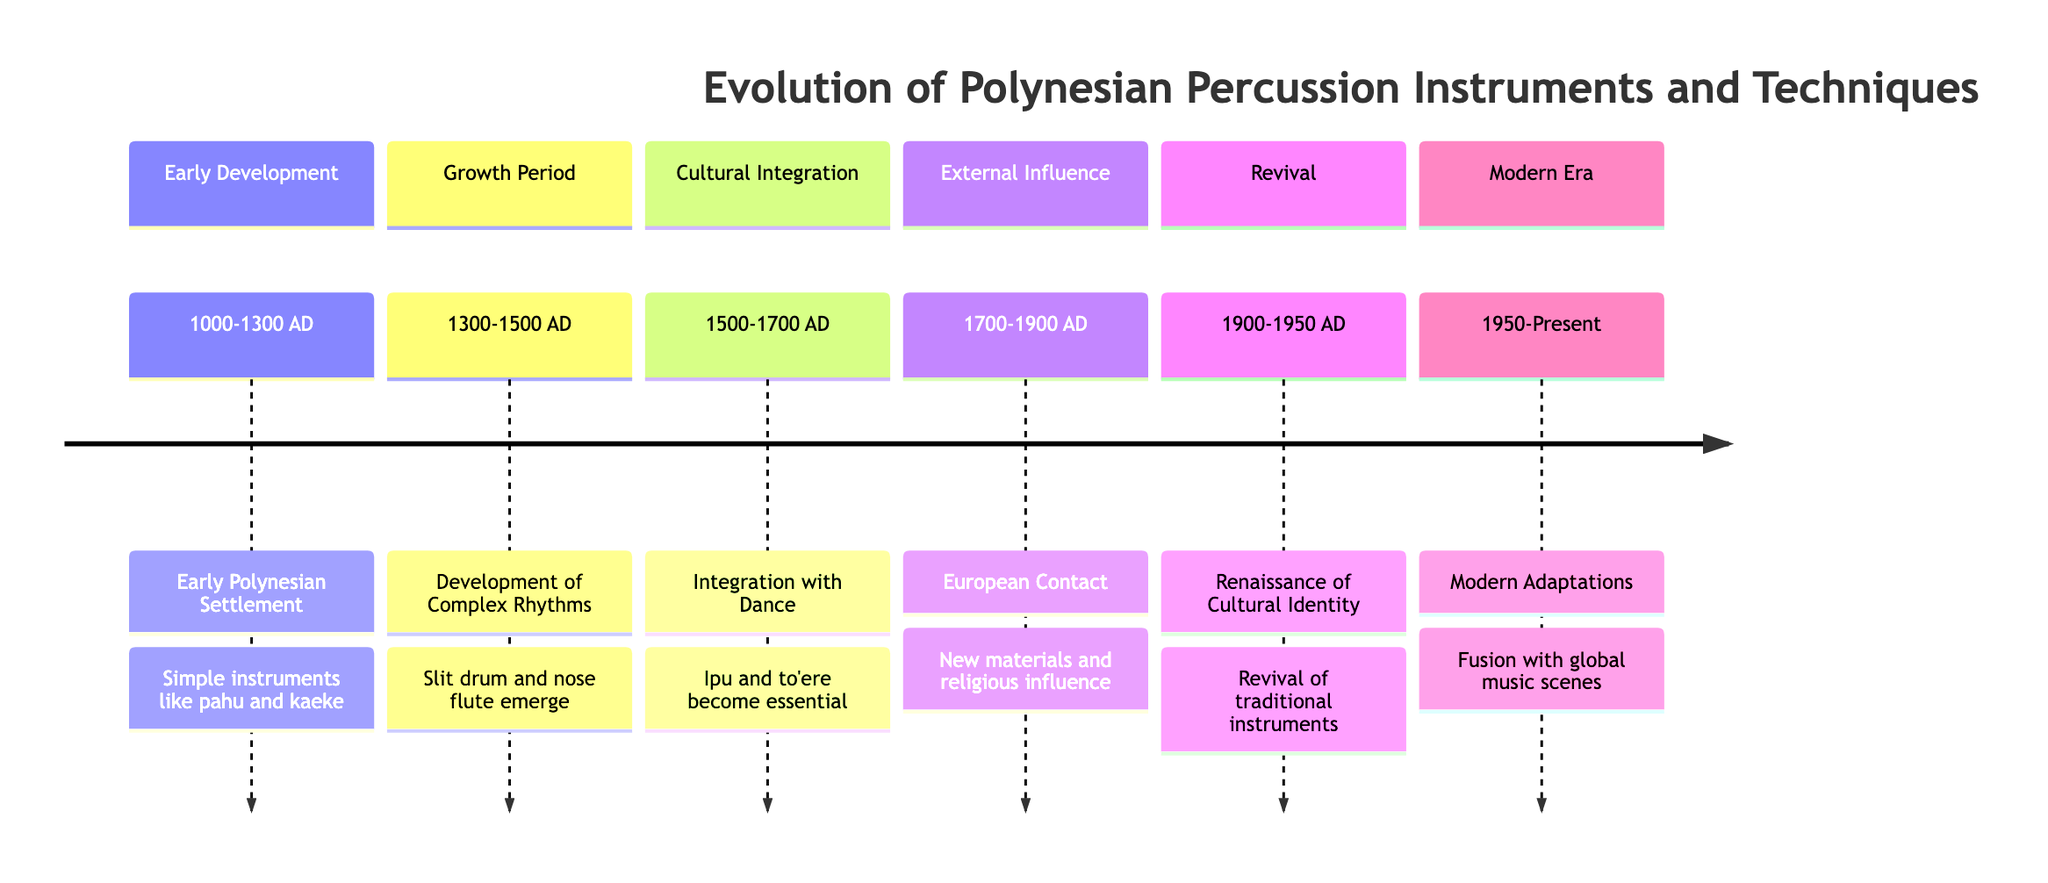What period marks the early Polynesian settlement? The timeline states that the early Polynesian settlement occurred from 1000 to 1300 AD. This period is the first entry in the timeline, indicating it is chronologically the earliest event listed.
Answer: 1000-1300 AD Which percussion instruments were mentioned in the early development section? The early development section lists the simple instruments introduced during the early Polynesian settlement, specifically mentioning pahu (drums) and kaeke (log drums) as crucial to rituals and entertainment.
Answer: pahu and kaeke What significant change occurred during the period 1700-1900 AD? This period is characterized by European contact, which introduced new materials and ideas. Following this contact, traditional instruments saw decline while some adapted to include new elements such as metal components in drums. The timeline specifies that the arrival of missionaries also influenced the use of instruments.
Answer: European contact How many different sections are featured in the timeline? By examining the structure of the timeline, we can count the number of distinct sections outlined. There are a total of six sections listed: Early Development, Growth Period, Cultural Integration, External Influence, Revival, and Modern Era.
Answer: 6 What instruments became essential in the integration with dance? The timeline indicates that the integration of Polynesian percussion with dance and oral traditions saw the rise in prominence of specific instruments. It explicitly mentions the ipu (gourd drum) and to'ere (wooden slit drum) as becoming essential to performances and storytelling.
Answer: ipu and to'ere During which period did the Renaissance of Polynesian Cultural Identity occur? The timeline clearly states that the Renaissance of Polynesian Cultural Identity took place between 1900 and 1950 AD, marking a significant revival of traditional percussion instruments and cultural practices during this time.
Answer: 1900-1950 AD What rhythmic patterns became central to many cultural ceremonies from 1300-1500 AD? This period highlights the development of complex rhythms alongside expanded percussion instruments. It specifically notes that matagi, which are rhythmic patterns, became central to many cultural ceremonies during this growth period.
Answer: matagi Which section of the timeline indicates modernization and global integration? The final section of the timeline, labeled "Modern Era," is dedicated to describing the modernization and global influence of Polynesian percussion instruments and techniques, indicating the evolution of their use in contemporary settings.
Answer: Modern Era 